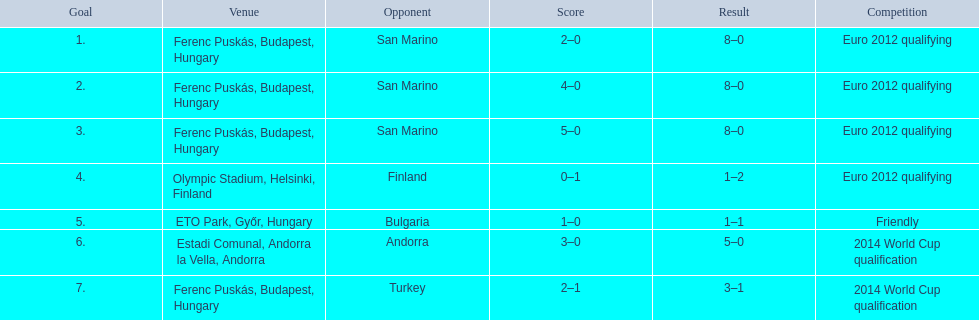What is the cumulative sum of international goals made by ádám szalai? 7. 